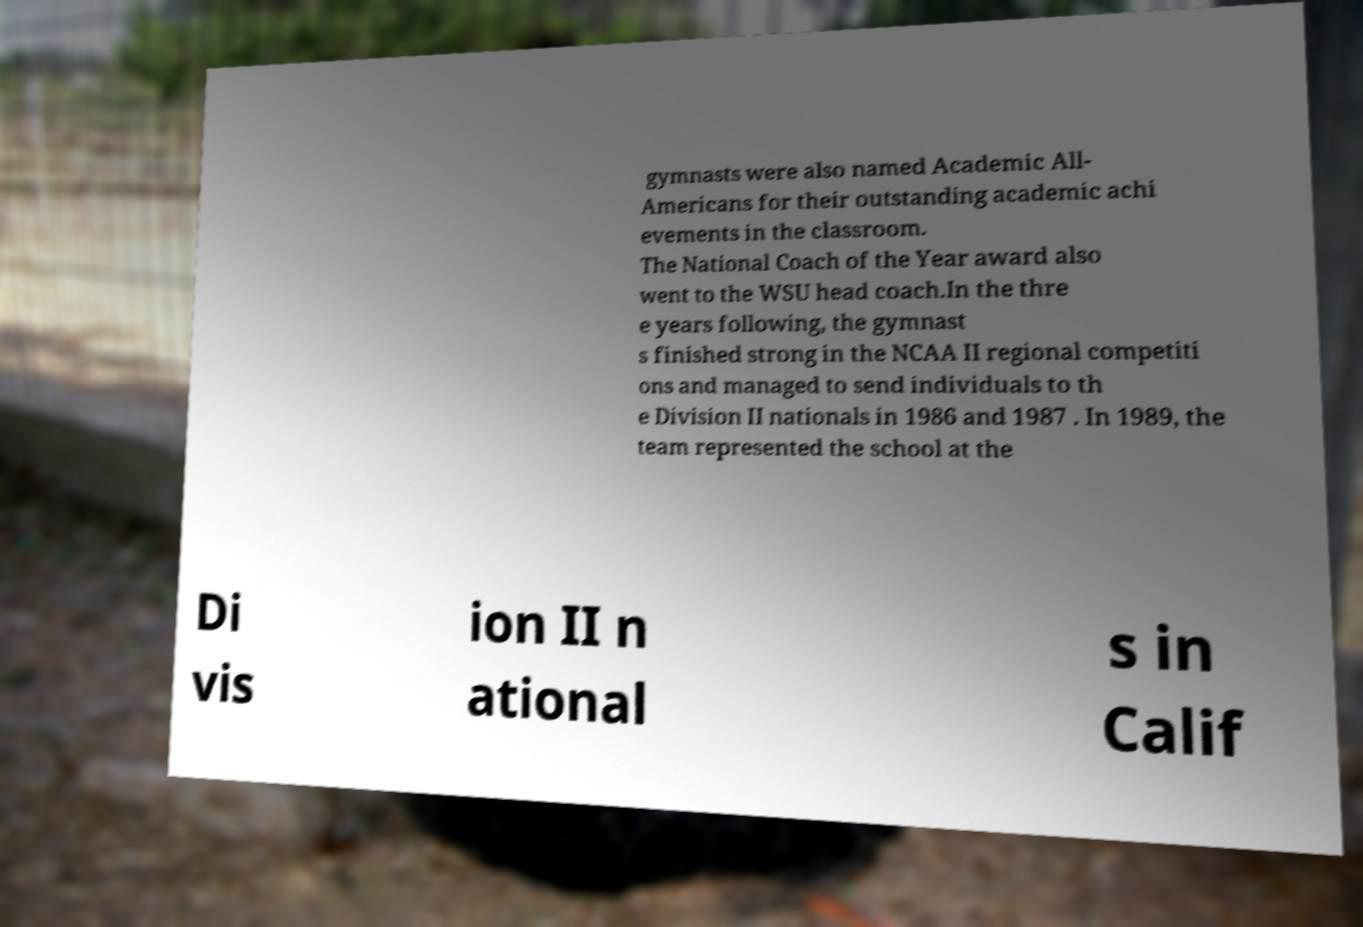I need the written content from this picture converted into text. Can you do that? gymnasts were also named Academic All- Americans for their outstanding academic achi evements in the classroom. The National Coach of the Year award also went to the WSU head coach.In the thre e years following, the gymnast s finished strong in the NCAA II regional competiti ons and managed to send individuals to th e Division II nationals in 1986 and 1987 . In 1989, the team represented the school at the Di vis ion II n ational s in Calif 